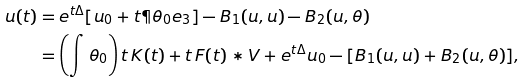<formula> <loc_0><loc_0><loc_500><loc_500>u ( t ) & = e ^ { t \Delta } [ u _ { 0 } + t \P \theta _ { 0 } e _ { 3 } ] - B _ { 1 } ( u , u ) - B _ { 2 } ( u , \theta ) \\ & = \left ( \int \theta _ { 0 } \right ) t \, K ( t ) + t \, F ( t ) * V + e ^ { t \Delta } u _ { 0 } - [ B _ { 1 } ( u , u ) + B _ { 2 } ( u , \theta ) ] ,</formula> 